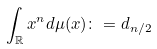<formula> <loc_0><loc_0><loc_500><loc_500>\int _ { \mathbb { R } } x ^ { n } d \mu ( x ) \colon = d _ { n / 2 }</formula> 